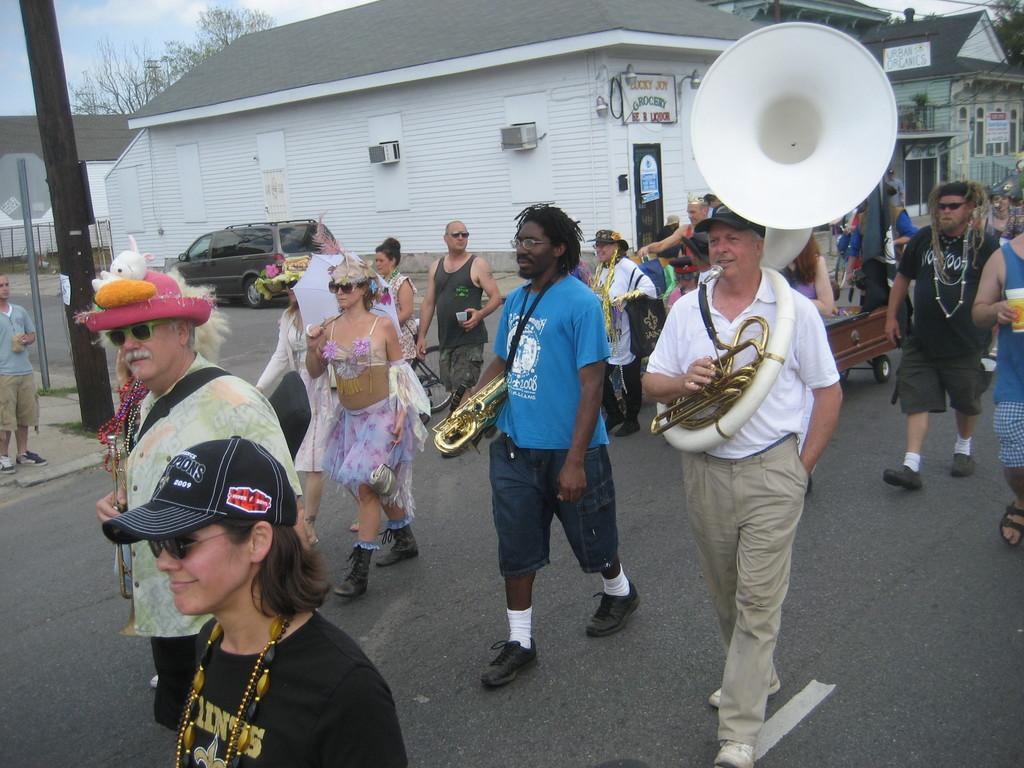Could you give a brief overview of what you see in this image? In this image there are a few persons walking down the streets by holding a few musical instruments in their hands, in the background of the image there is a car parked in front of a building. 